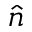Convert formula to latex. <formula><loc_0><loc_0><loc_500><loc_500>\widehat { n }</formula> 